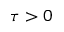<formula> <loc_0><loc_0><loc_500><loc_500>\tau > 0</formula> 